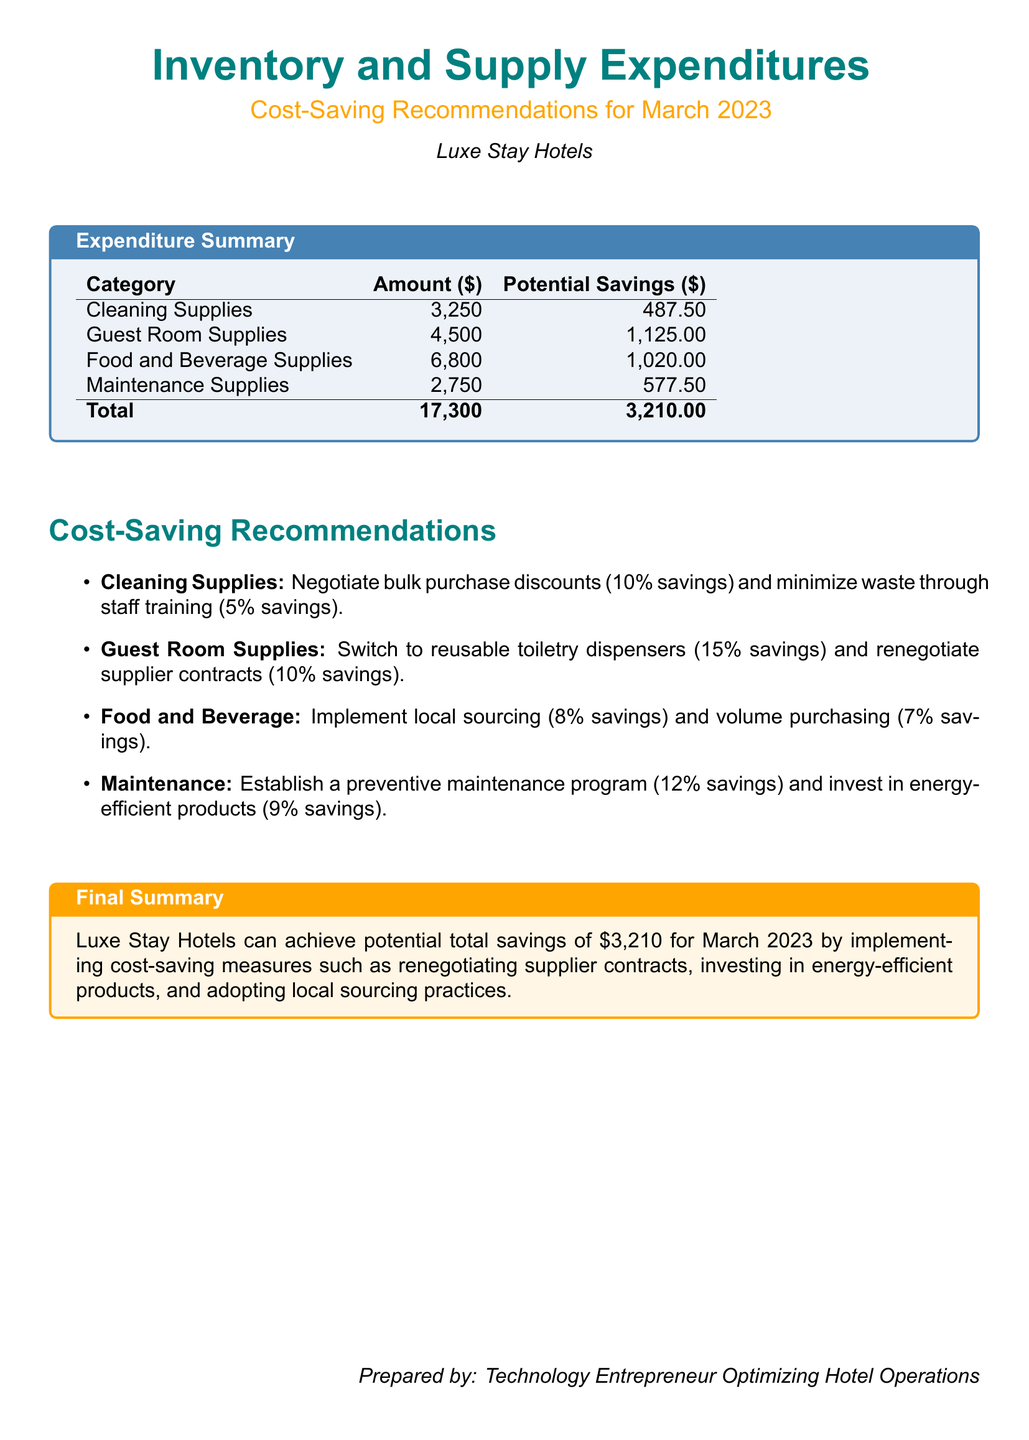what is the total expenditure for March 2023? The total expenditure is the sum of all categories listed in the document, which is $3,250 + $4,500 + $6,800 + $2,750 = $17,300.
Answer: $17,300 what are the potential savings for Guest Room Supplies? The potential savings for Guest Room Supplies is specified in the summary table as $1,125.
Answer: $1,125 which category has the highest expenditure? The category with the highest expenditure is Food and Beverage Supplies with an amount of $6,800.
Answer: Food and Beverage Supplies what is the percentage saving from switching to reusable toiletry dispensers? The document states that switching to reusable toiletry dispensers could lead to a savings of 15%.
Answer: 15% how much total potential savings can be achieved by implementing the recommendations? The document summarizes the total potential savings by adding all categories, which is $3,210.
Answer: $3,210 what is one recommendation for reducing costs related to Maintenance Supplies? The document mentions establishing a preventive maintenance program as a recommendation for Maintenance Supplies.
Answer: Establish a preventive maintenance program how much can be saved by negotiating bulk purchase discounts for Cleaning Supplies? The document indicates that negotiating bulk purchase discounts could lead to a savings of 10%.
Answer: 10% who prepared the document? The document is prepared by a technology entrepreneur optimizing hotel operations.
Answer: Technology Entrepreneur Optimizing Hotel Operations 